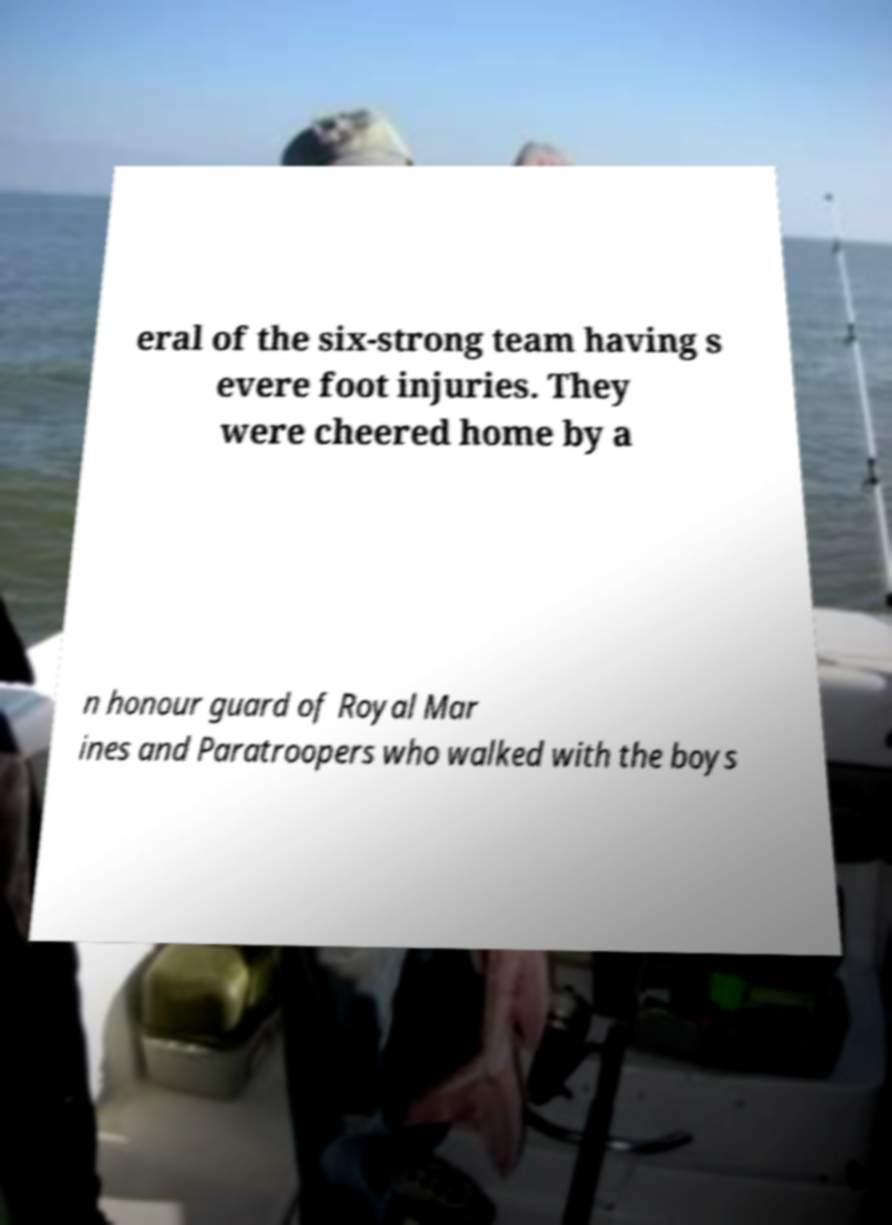Could you assist in decoding the text presented in this image and type it out clearly? eral of the six-strong team having s evere foot injuries. They were cheered home by a n honour guard of Royal Mar ines and Paratroopers who walked with the boys 